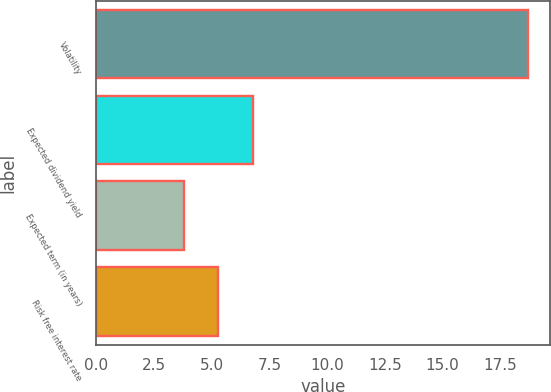Convert chart to OTSL. <chart><loc_0><loc_0><loc_500><loc_500><bar_chart><fcel>Volatility<fcel>Expected dividend yield<fcel>Expected term (in years)<fcel>Risk free interest rate<nl><fcel>18.7<fcel>6.78<fcel>3.8<fcel>5.29<nl></chart> 